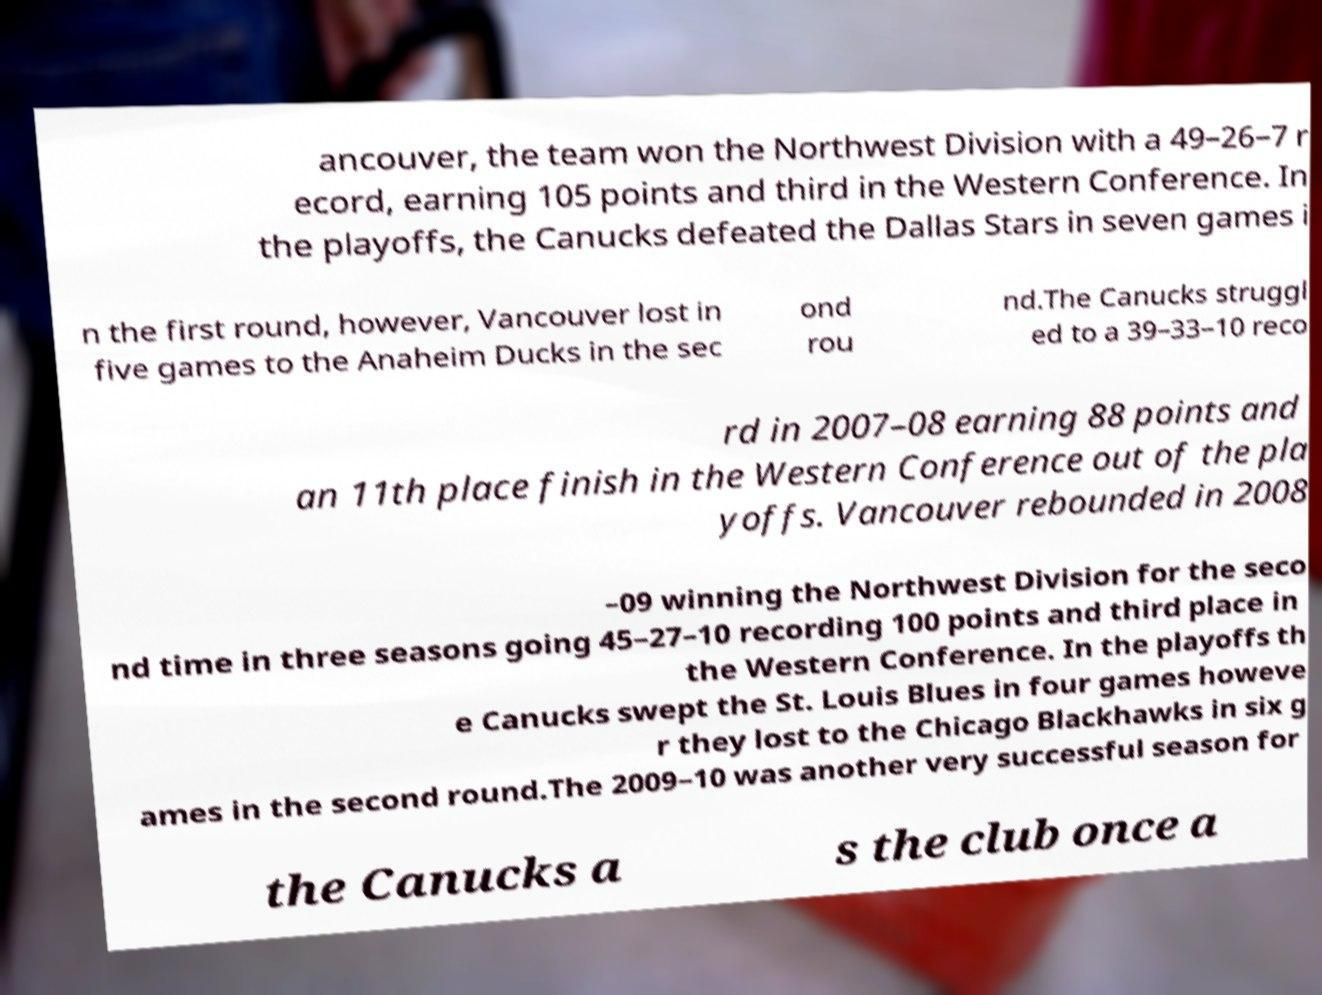Please read and relay the text visible in this image. What does it say? ancouver, the team won the Northwest Division with a 49–26–7 r ecord, earning 105 points and third in the Western Conference. In the playoffs, the Canucks defeated the Dallas Stars in seven games i n the first round, however, Vancouver lost in five games to the Anaheim Ducks in the sec ond rou nd.The Canucks struggl ed to a 39–33–10 reco rd in 2007–08 earning 88 points and an 11th place finish in the Western Conference out of the pla yoffs. Vancouver rebounded in 2008 –09 winning the Northwest Division for the seco nd time in three seasons going 45–27–10 recording 100 points and third place in the Western Conference. In the playoffs th e Canucks swept the St. Louis Blues in four games howeve r they lost to the Chicago Blackhawks in six g ames in the second round.The 2009–10 was another very successful season for the Canucks a s the club once a 